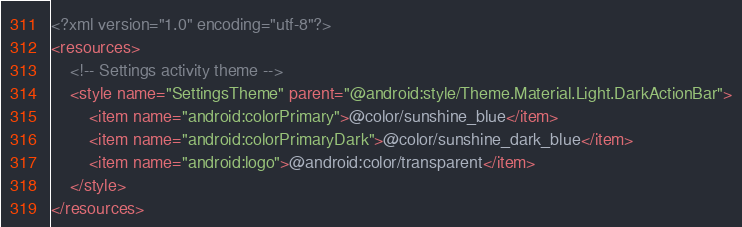<code> <loc_0><loc_0><loc_500><loc_500><_XML_><?xml version="1.0" encoding="utf-8"?>
<resources>
    <!-- Settings activity theme -->
    <style name="SettingsTheme" parent="@android:style/Theme.Material.Light.DarkActionBar">
        <item name="android:colorPrimary">@color/sunshine_blue</item>
        <item name="android:colorPrimaryDark">@color/sunshine_dark_blue</item>
        <item name="android:logo">@android:color/transparent</item>
    </style>
</resources></code> 